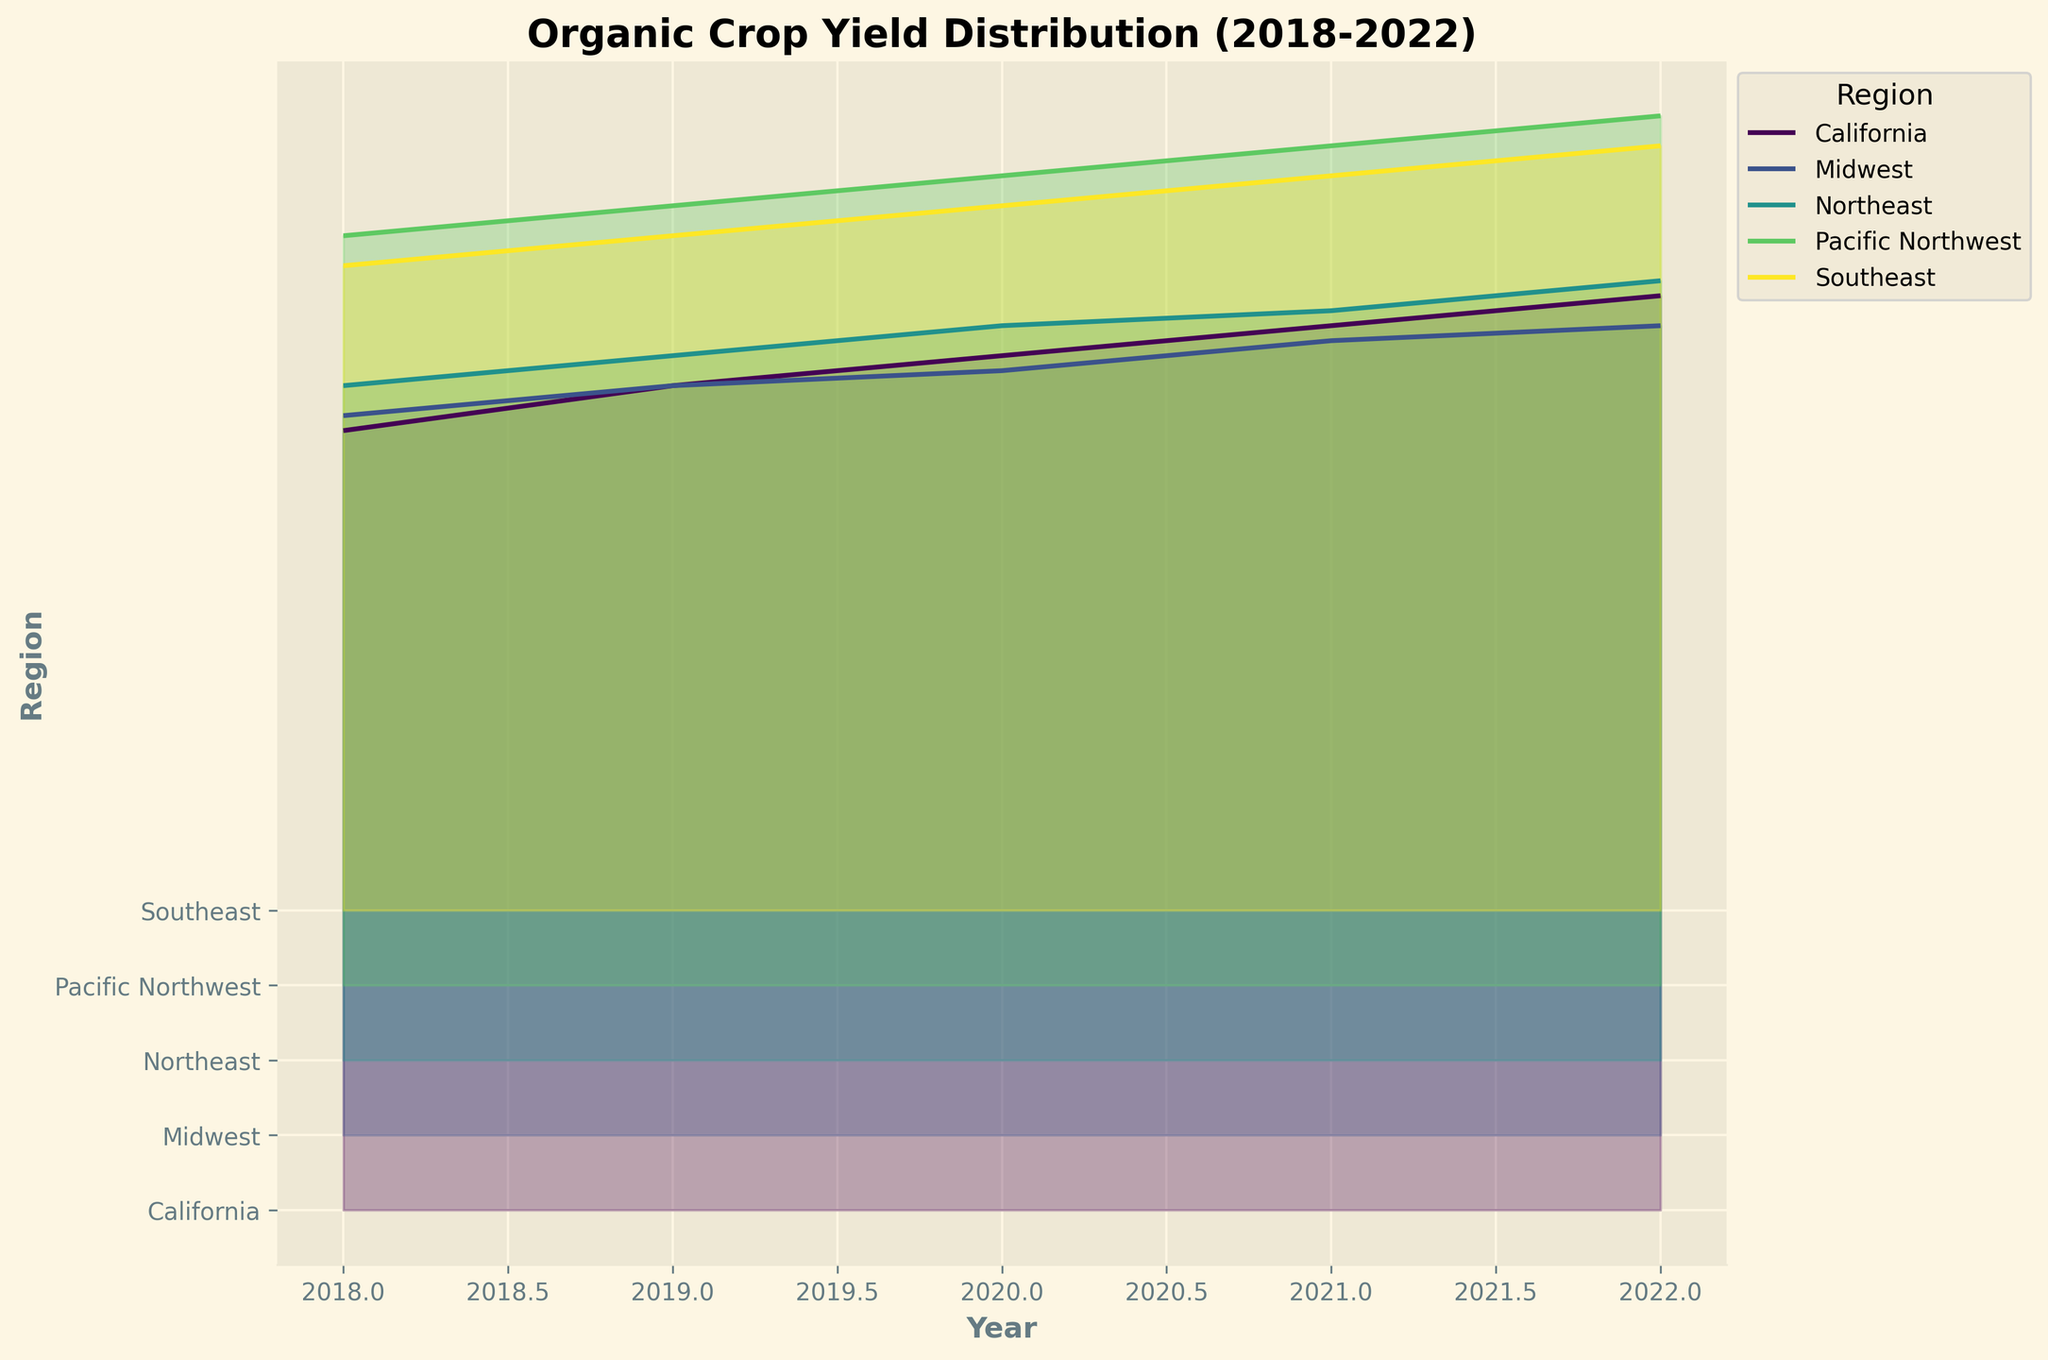What is the title of the plot? The title is typically at the top of the plot. Read the text there to identify the title.
Answer: Organic Crop Yield Distribution (2018-2022) Which region had the highest yield in 2022? Look at the last data points for the year 2022 across all regions and identify the highest point.
Answer: California How many regions are depicted in the plot? Count the distinct horizontal layers or labels (Y-axis) representing different regions.
Answer: 5 Which region showed a steady increase in yield every year from 2018 to 2022? Observe the trend lines for each region, looking for a consistent upward movement across the years.
Answer: California In which year did the Midwest surpass a yield of 5 tons per hectare for the first time? Identify the data points for the Midwest and check the yield values; find the first instance where it exceeds 5.
Answer: 2019 Compare the yields of Northeast and Southeast in 2020. Which was higher? Find the data points for the year 2020 for both Northeast and Southeast and compare their positions on the vertical axis.
Answer: Northeast What was the yield range of the Pacific Northwest from 2018 to 2022? Identify the minimum and maximum yield values for the Pacific Northwest across the given years. Subtract the minimum value from the maximum value to get the range.
Answer: 5.0 to 5.8, range = 0.8 Which region's yield increased the most from 2018 to 2022? Calculate the difference between the 2022 and 2018 yield values for each region and determine the highest value.
Answer: California Did any region experience a decline in yield in any year? Examine the trend lines for each region to check for any downward trends between consecutive years.
Answer: No How does the yield trend of the Southeast compare to the Pacific Northwest over the 5 years? Observe the overall trend for both regions; check if both have increasing trends and compare the slopes visually.
Answer: Both increasing, Pacific Northwest has a steeper increase 